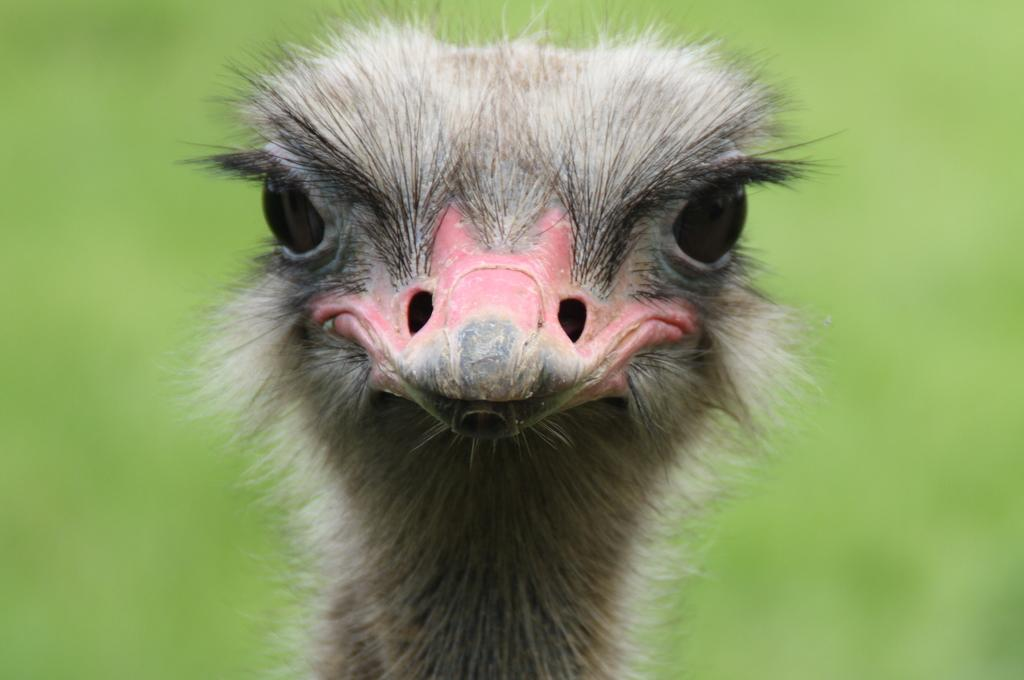What is the main subject of the image? The main subject of the image is the face of an ostrich. What type of destruction can be seen in the image? There is no destruction present in the image; it features the face of an ostrich. What is the income of the ostrich in the image? There is no information about the income of the ostrich in the image, as it is a static image and not a living creature with an income. 